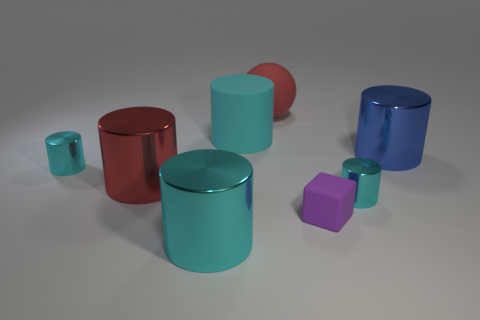How many cyan cylinders must be subtracted to get 2 cyan cylinders? 2 Subtract all large cyan cylinders. How many cylinders are left? 4 Subtract all brown cubes. How many cyan cylinders are left? 4 Add 1 small shiny cylinders. How many objects exist? 9 Subtract all cyan cylinders. How many cylinders are left? 2 Subtract all cylinders. How many objects are left? 2 Add 7 big blue matte spheres. How many big blue matte spheres exist? 7 Subtract 0 purple cylinders. How many objects are left? 8 Subtract all brown balls. Subtract all brown cylinders. How many balls are left? 1 Subtract all small metallic things. Subtract all small cyan metal things. How many objects are left? 4 